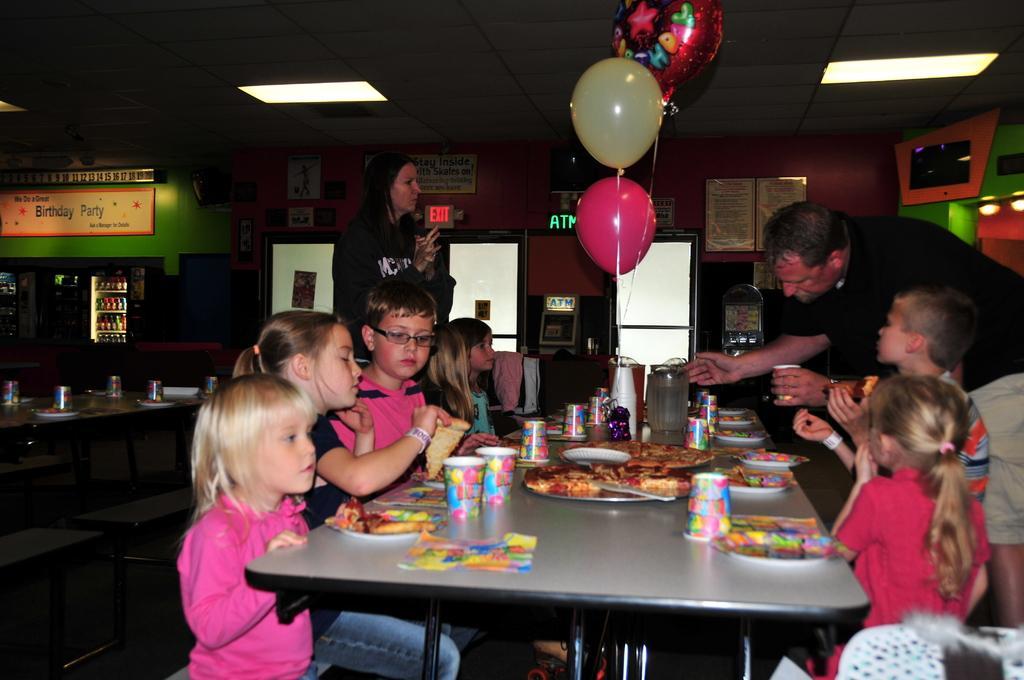Please provide a concise description of this image. A couple are arranging food items to children at a birthday party. 